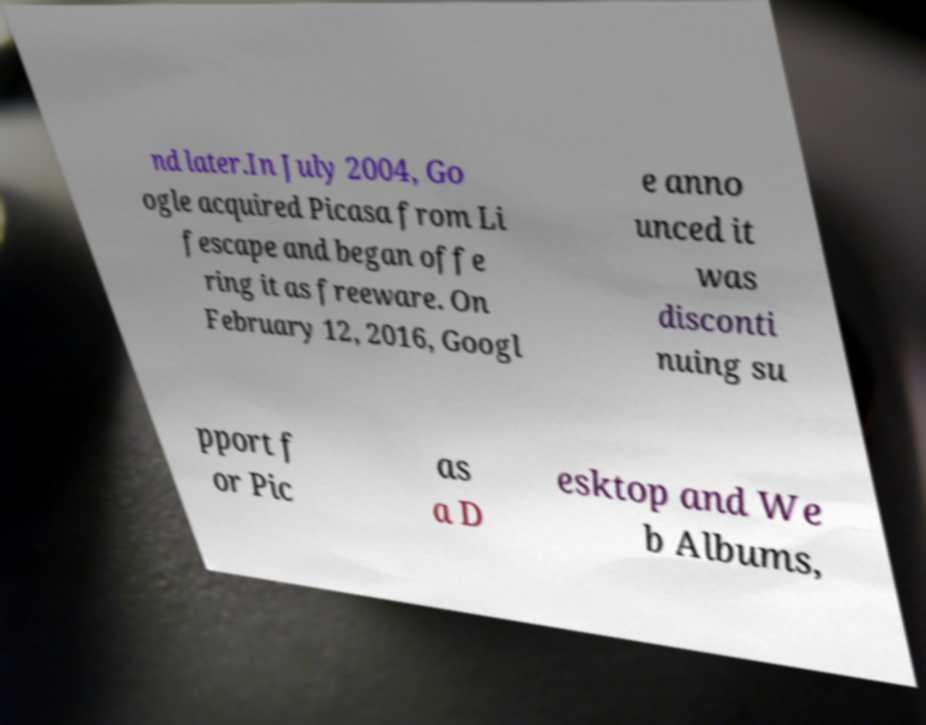There's text embedded in this image that I need extracted. Can you transcribe it verbatim? nd later.In July 2004, Go ogle acquired Picasa from Li fescape and began offe ring it as freeware. On February 12, 2016, Googl e anno unced it was disconti nuing su pport f or Pic as a D esktop and We b Albums, 